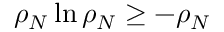<formula> <loc_0><loc_0><loc_500><loc_500>\rho _ { N } \ln \rho _ { N } \geq - \rho _ { N }</formula> 